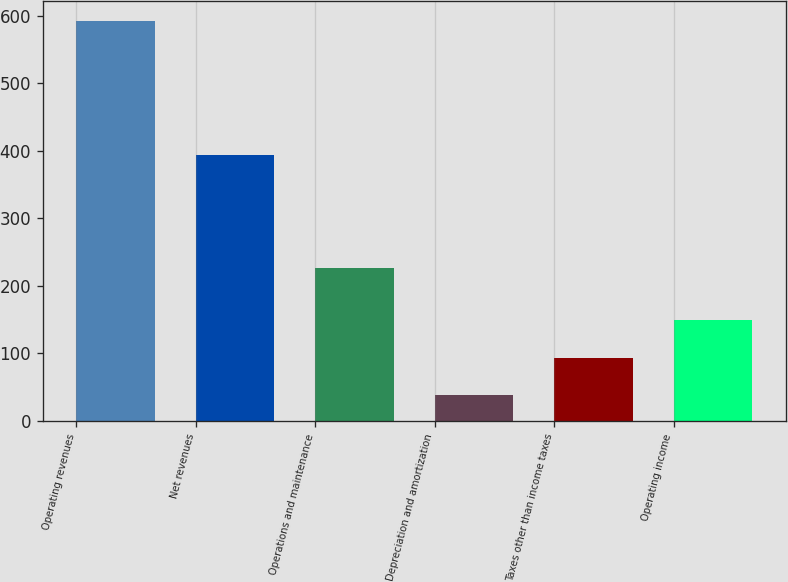Convert chart. <chart><loc_0><loc_0><loc_500><loc_500><bar_chart><fcel>Operating revenues<fcel>Net revenues<fcel>Operations and maintenance<fcel>Depreciation and amortization<fcel>Taxes other than income taxes<fcel>Operating income<nl><fcel>592<fcel>394<fcel>227<fcel>38<fcel>93.4<fcel>148.8<nl></chart> 